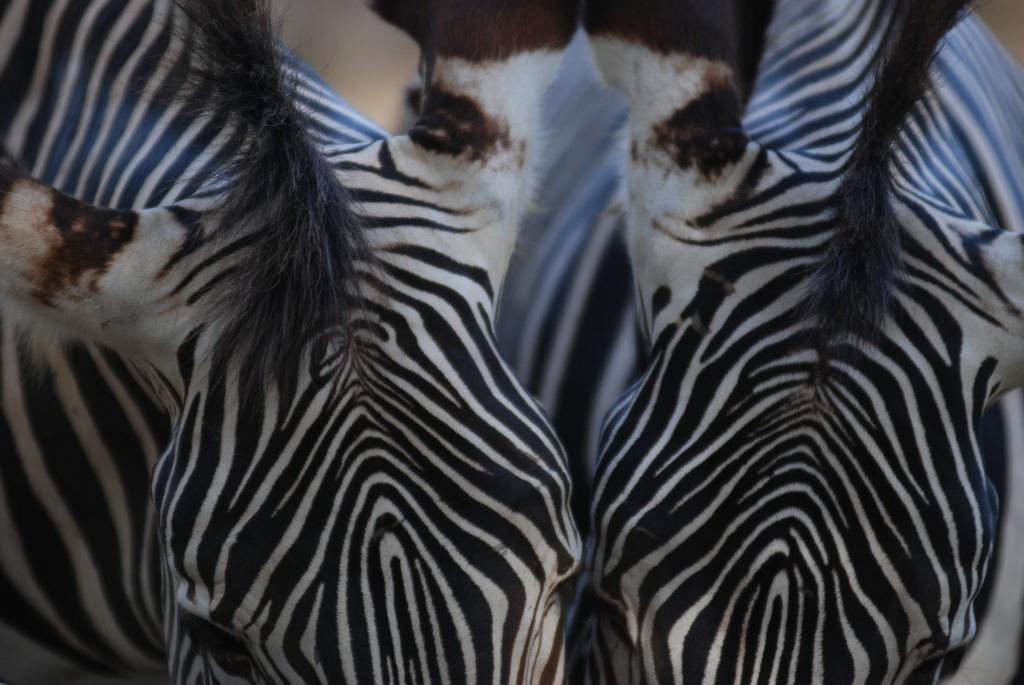Could you give a brief overview of what you see in this image? This is the picture of two zebras. 